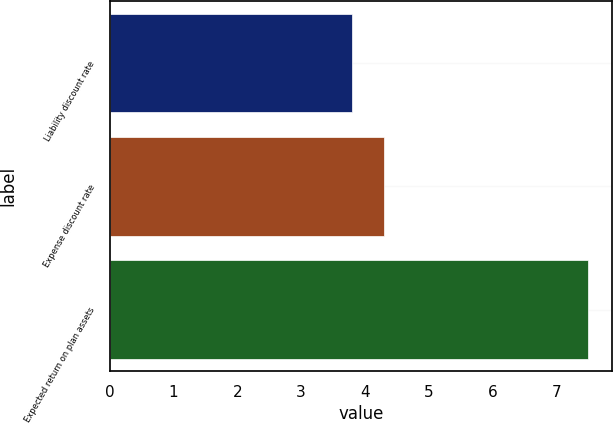Convert chart to OTSL. <chart><loc_0><loc_0><loc_500><loc_500><bar_chart><fcel>Liability discount rate<fcel>Expense discount rate<fcel>Expected return on plan assets<nl><fcel>3.8<fcel>4.3<fcel>7.5<nl></chart> 